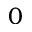<formula> <loc_0><loc_0><loc_500><loc_500>0</formula> 